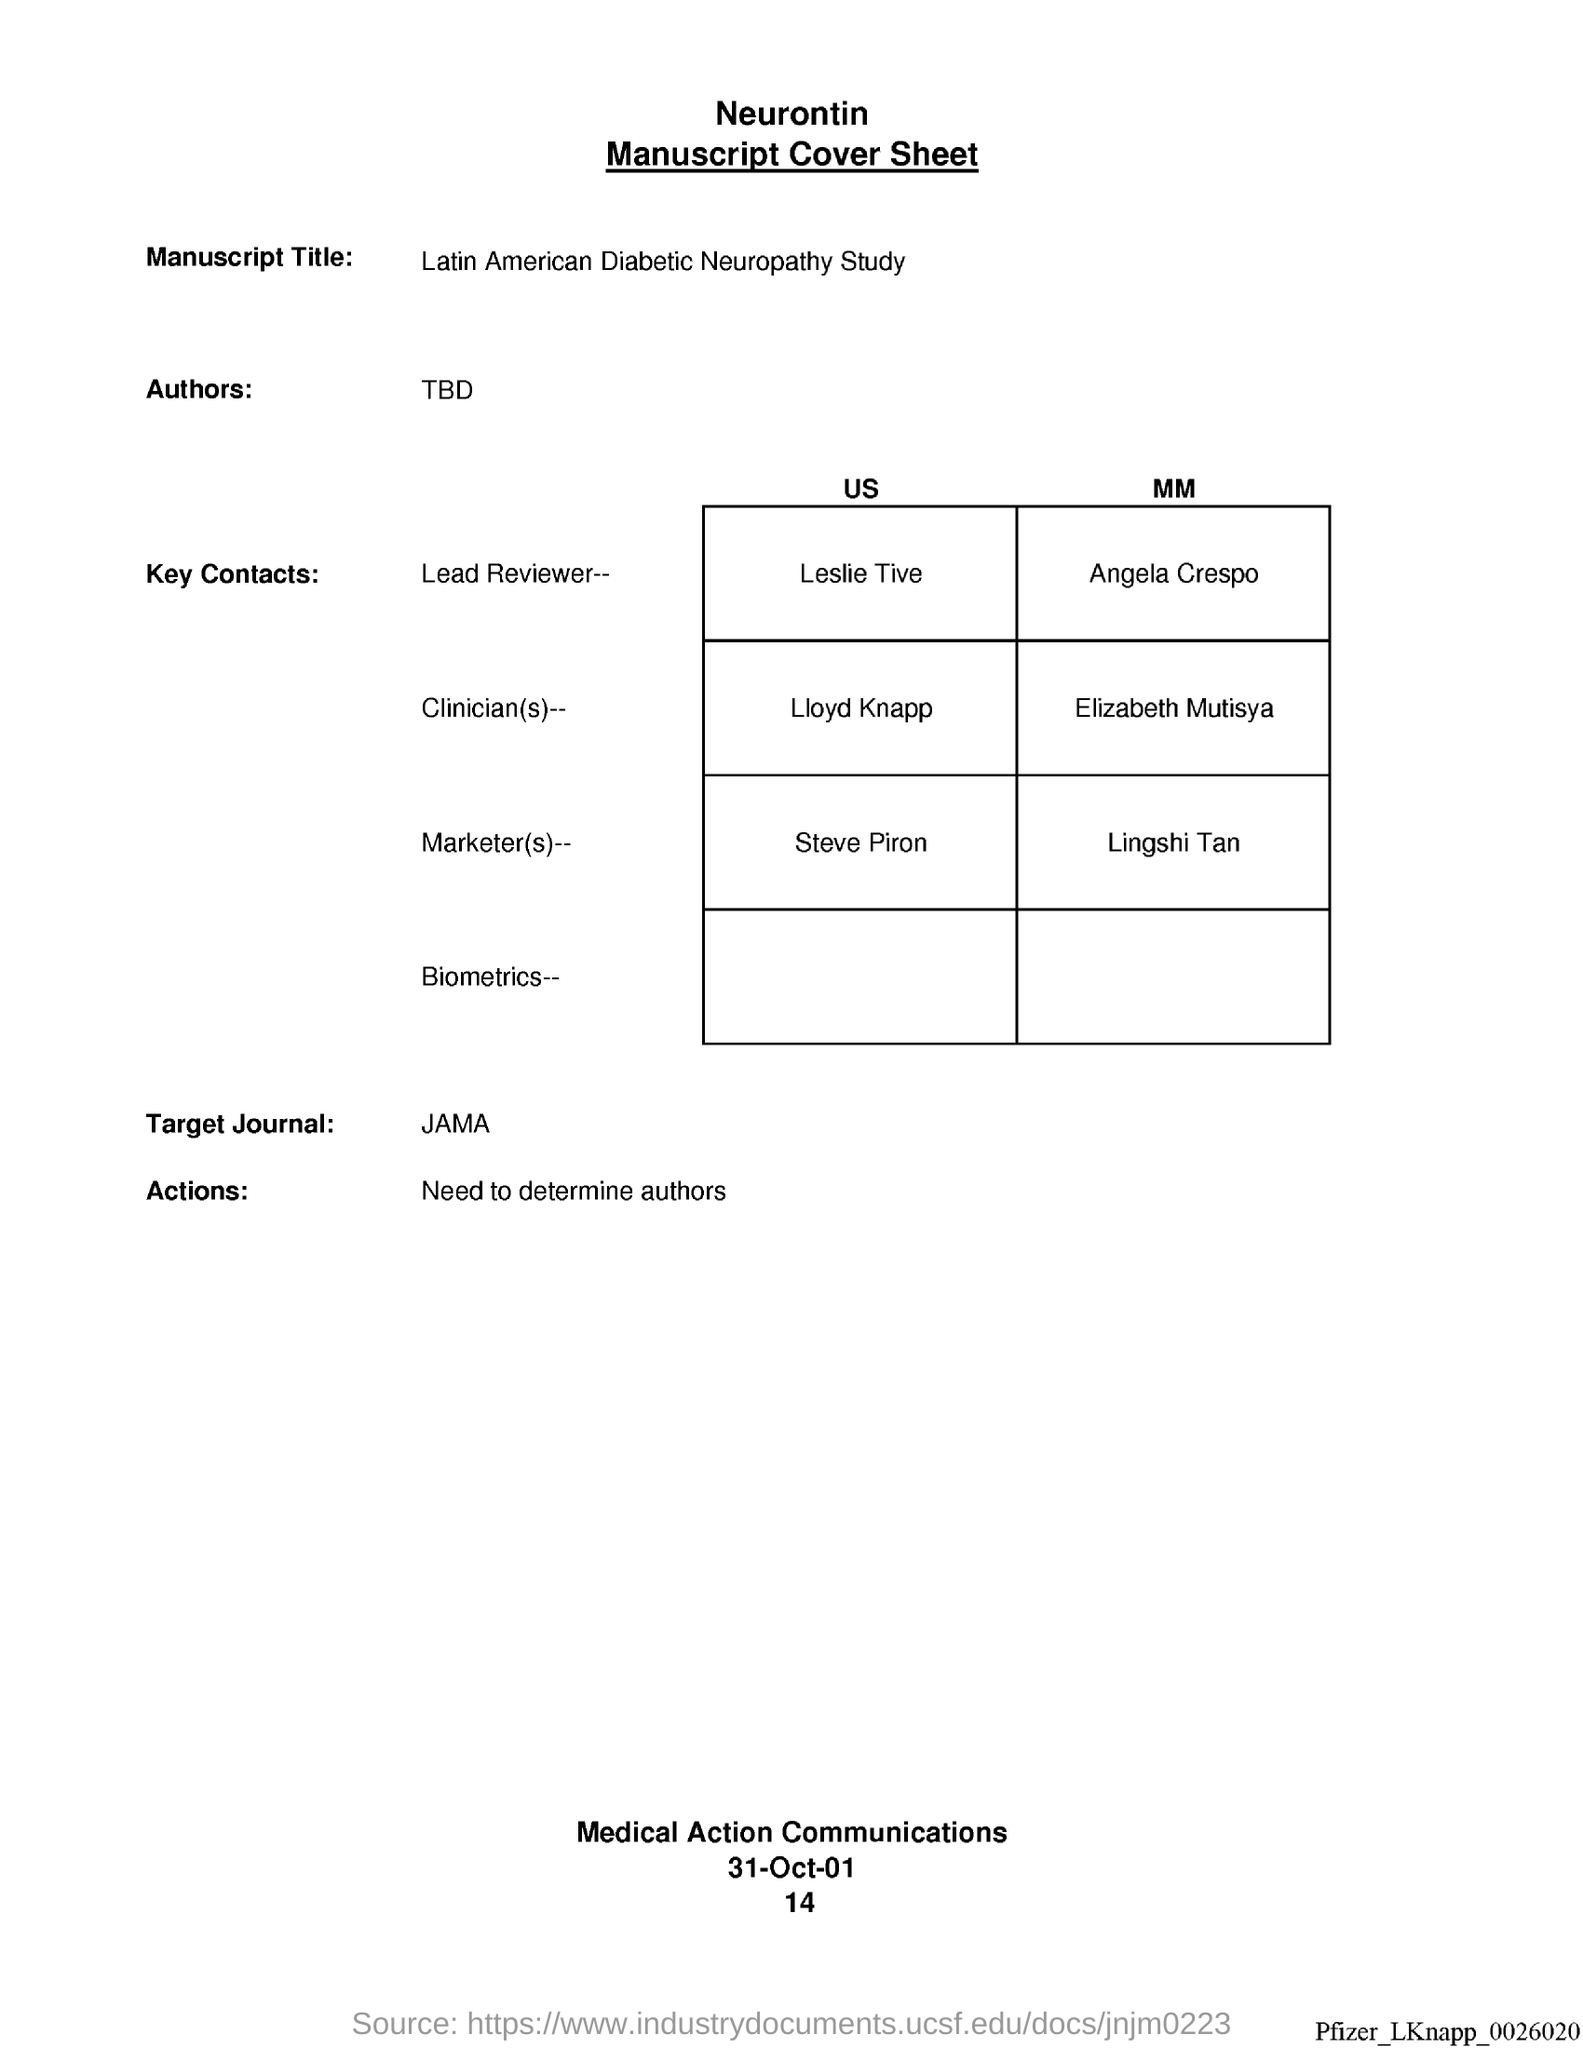Highlight a few significant elements in this photo. The date at the bottom of the page is 31 October 2001. The market(s) is/are MM, the lingshi tan... The clinician is Elizabeth Mutisya. I want to know if there is a page number on or before the specified date, which is January 14th. The target journal is JAMA. 